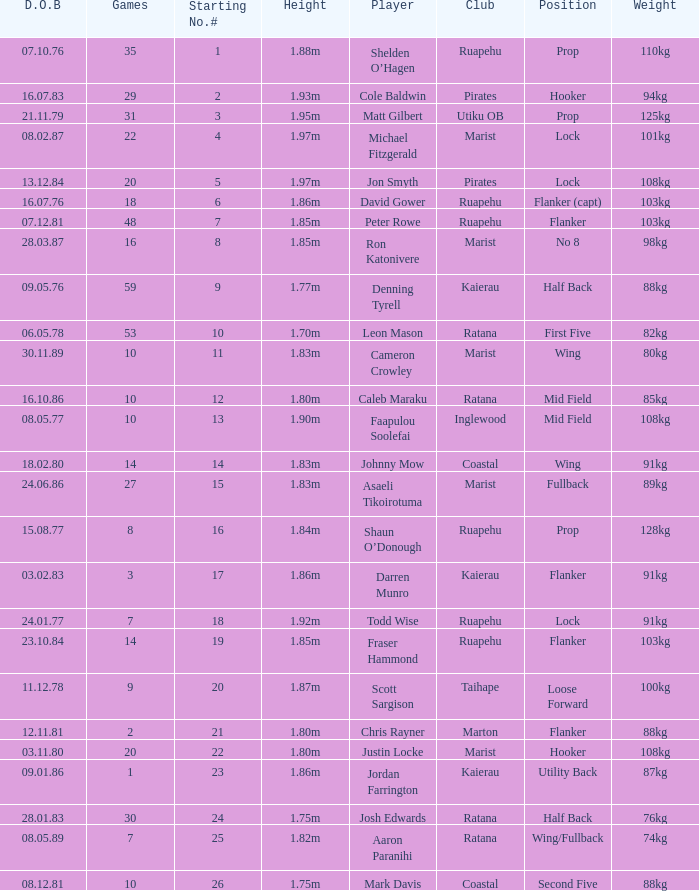Which player weighs 76kg? Josh Edwards. 